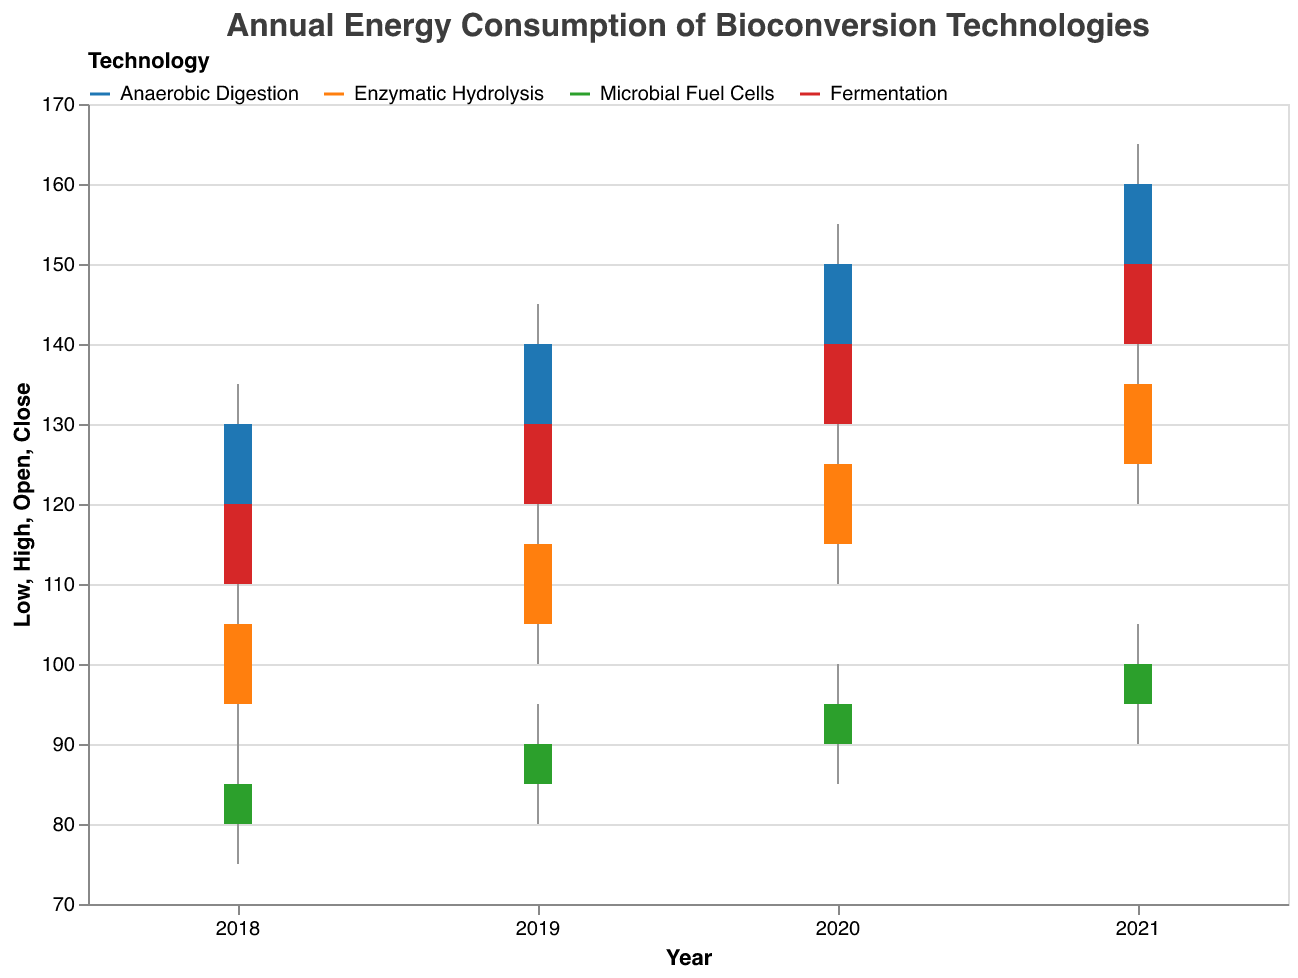What is the title of the figure? The title of the figure is mentioned at the top of the chart.
Answer: Annual Energy Consumption of Bioconversion Technologies Which technology had the highest energy consumption closed price in 2021? Looking at the data for 2021, the highest close value is 160 for Anaerobic Digestion.
Answer: Anaerobic Digestion Which technology showed the greatest improvement in energy consumption efficiency from 2018 to 2021? To determine this, compare the close values from 2018 to 2021 for each technology:
- Anaerobic Digestion: 130 to 160 (increase of 30)
- Enzymatic Hydrolysis: 105 to 135 (increase of 30)
- Microbial Fuel Cells: 85 to 100 (increase of 15)
- Fermentation: 120 to 150 (increase of 30)
Anaerobic Digestion, Enzymatic Hydrolysis, and Fermentation all had the greatest improvement with an increase of 30 units.
Answer: Anaerobic Digestion, Enzymatic Hydrolysis, Fermentation What was the open energy consumption price for Enzymatic Hydrolysis in 2020? Refer to the 2020 row for Enzymatic Hydrolysis, the open price is listed as 115.
Answer: 115 What is the range of energy consumption for Microbial Fuel Cells in 2019? The range is calculated as the difference between the high and low values for 2019:
- High: 95
- Low: 80
Hence, the range is 95 - 80 = 15.
Answer: 15 Compare the trend in energy consumption between Anaerobic Digestion and Microbial Fuel Cells from 2018 to 2021. Anaerobic Digestion: 
- 2018: 130, 2019: 140, 2020: 150, 2021: 160 (steady increase each year)
Microbial Fuel Cells: 
- 2018: 85, 2019: 90, 2020: 95, 2021: 100 (steady increase each year)
Both technologies show a consistent increase, but Anaerobic Digestion has higher overall values and larger increases.
Answer: Both increased, Anaerobic Digestion had higher values In which year did Fermentation have its lowest energy consumption close price? Refer to the close values for Fermentation across the years:
- 2018: 120
- 2019: 130
- 2020: 140
- 2021: 150
The lowest close price is 120 in 2018.
Answer: 2018 Did Enzymatic Hydrolysis ever have higher close values than Anaerobic Digestion? Compare the close values for each year:
- 2018: 105 vs 130
- 2019: 115 vs 140
- 2020: 125 vs 150
- 2021: 135 vs 160
Enzymatic Hydrolysis never had higher values than Anaerobic Digestion.
Answer: No 